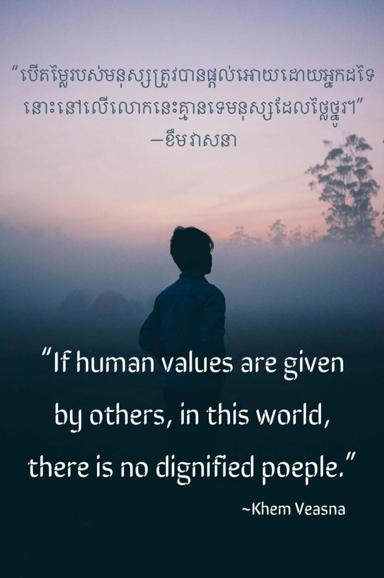What do you think the quote means? Khem Veasna's quote asserts that true dignity arises from developing one's own values rather than adopting those imposed by others. It invites a reflection on autonomy and integrity, suggesting that societal pressures and external values can compromise individual freedom and self-respect, thus undermining the diversity of human perspectives and leading to a homogenized society where individual distinctiveness is undervalued. 